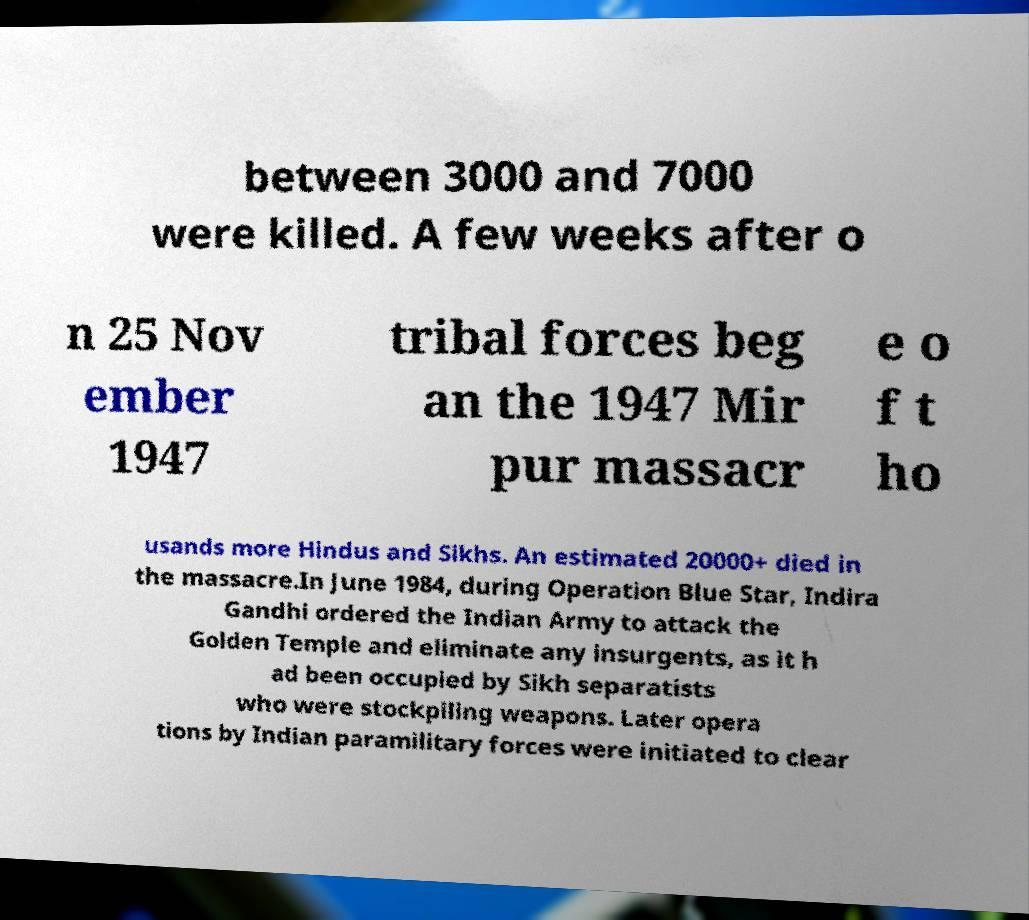Can you read and provide the text displayed in the image?This photo seems to have some interesting text. Can you extract and type it out for me? between 3000 and 7000 were killed. A few weeks after o n 25 Nov ember 1947 tribal forces beg an the 1947 Mir pur massacr e o f t ho usands more Hindus and Sikhs. An estimated 20000+ died in the massacre.In June 1984, during Operation Blue Star, Indira Gandhi ordered the Indian Army to attack the Golden Temple and eliminate any insurgents, as it h ad been occupied by Sikh separatists who were stockpiling weapons. Later opera tions by Indian paramilitary forces were initiated to clear 